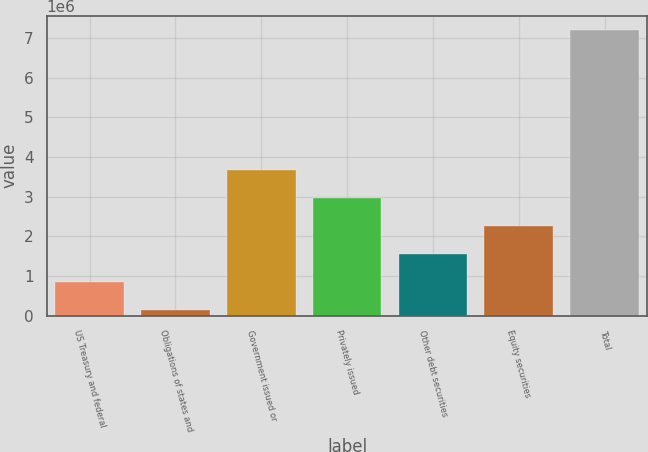Convert chart. <chart><loc_0><loc_0><loc_500><loc_500><bar_chart><fcel>US Treasury and federal<fcel>Obligations of states and<fcel>Government issued or<fcel>Privately issued<fcel>Other debt securities<fcel>Equity securities<fcel>Total<nl><fcel>842223<fcel>136186<fcel>3.66637e+06<fcel>2.96033e+06<fcel>1.54826e+06<fcel>2.2543e+06<fcel>7.19655e+06<nl></chart> 